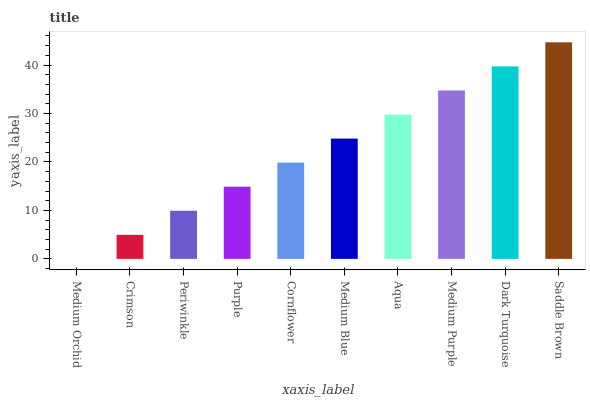Is Crimson the minimum?
Answer yes or no. No. Is Crimson the maximum?
Answer yes or no. No. Is Crimson greater than Medium Orchid?
Answer yes or no. Yes. Is Medium Orchid less than Crimson?
Answer yes or no. Yes. Is Medium Orchid greater than Crimson?
Answer yes or no. No. Is Crimson less than Medium Orchid?
Answer yes or no. No. Is Medium Blue the high median?
Answer yes or no. Yes. Is Cornflower the low median?
Answer yes or no. Yes. Is Crimson the high median?
Answer yes or no. No. Is Purple the low median?
Answer yes or no. No. 